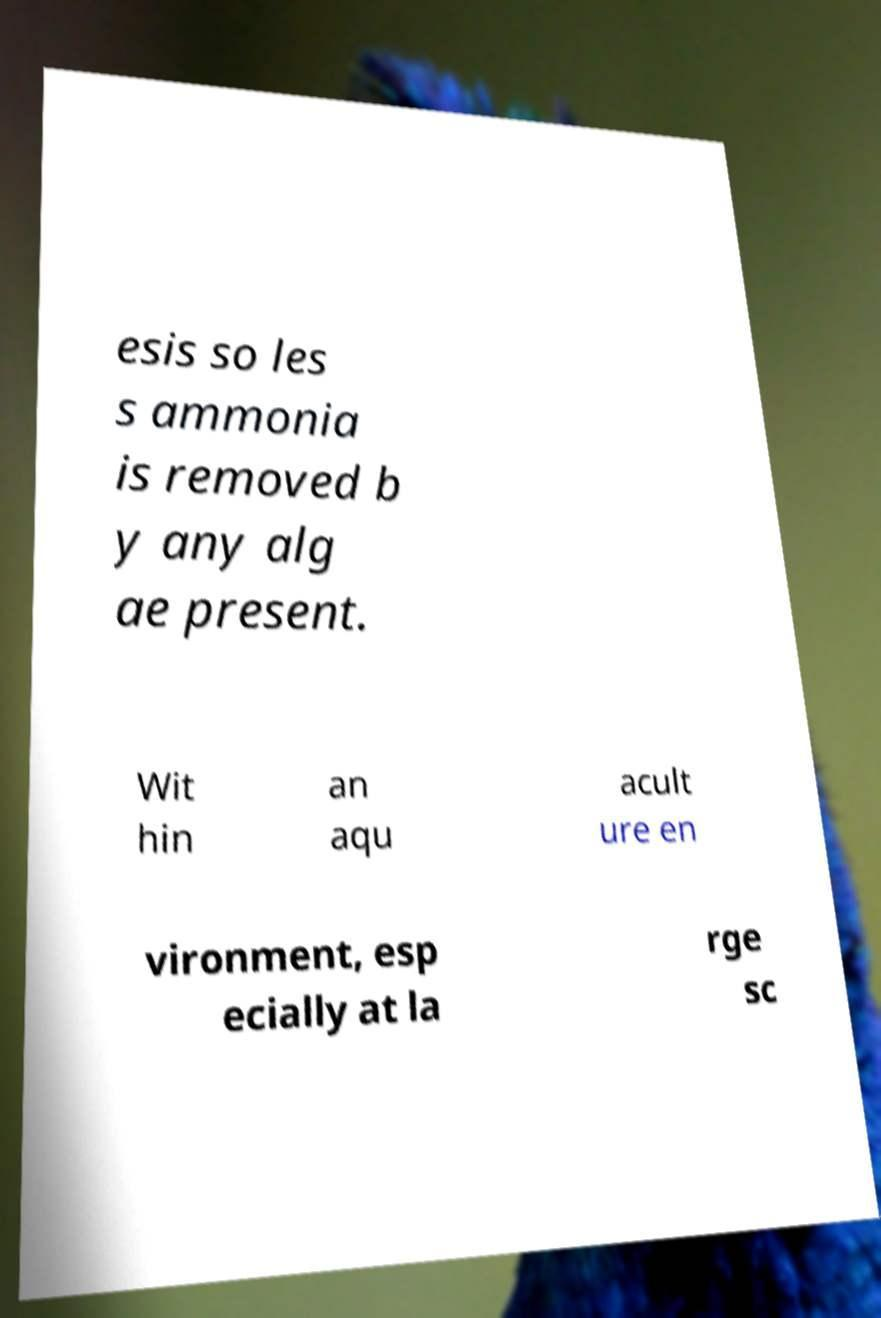Can you read and provide the text displayed in the image?This photo seems to have some interesting text. Can you extract and type it out for me? esis so les s ammonia is removed b y any alg ae present. Wit hin an aqu acult ure en vironment, esp ecially at la rge sc 